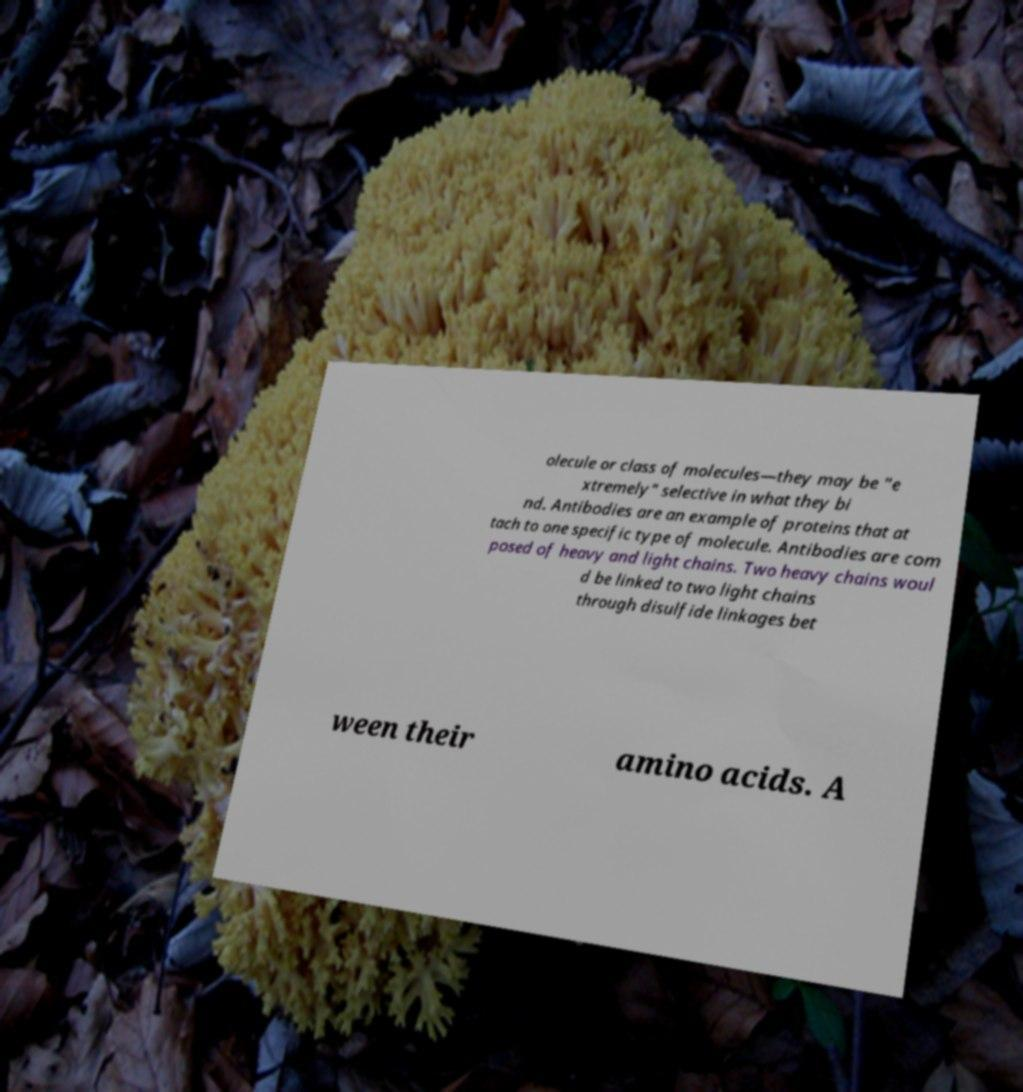Could you extract and type out the text from this image? olecule or class of molecules—they may be "e xtremely" selective in what they bi nd. Antibodies are an example of proteins that at tach to one specific type of molecule. Antibodies are com posed of heavy and light chains. Two heavy chains woul d be linked to two light chains through disulfide linkages bet ween their amino acids. A 